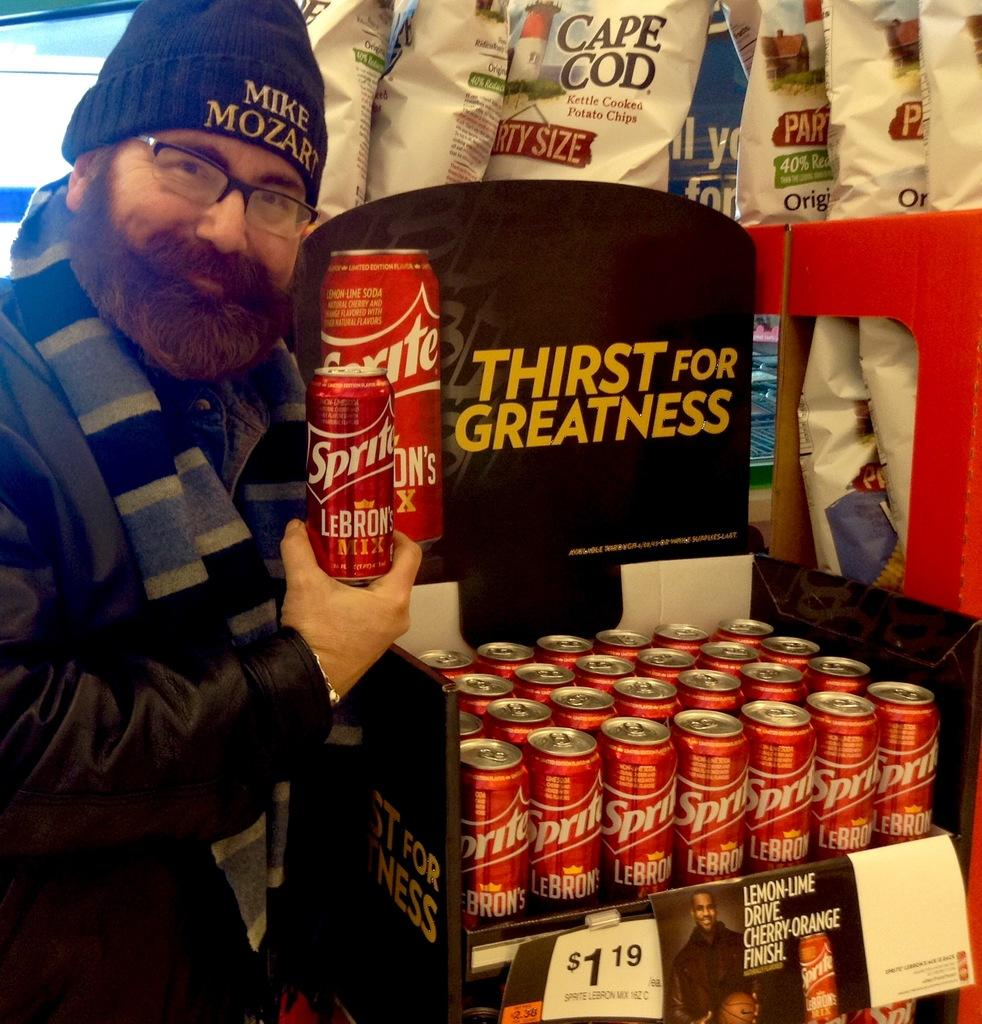<image>
Relay a brief, clear account of the picture shown. A man holds a red can of Sprite in his hand. 